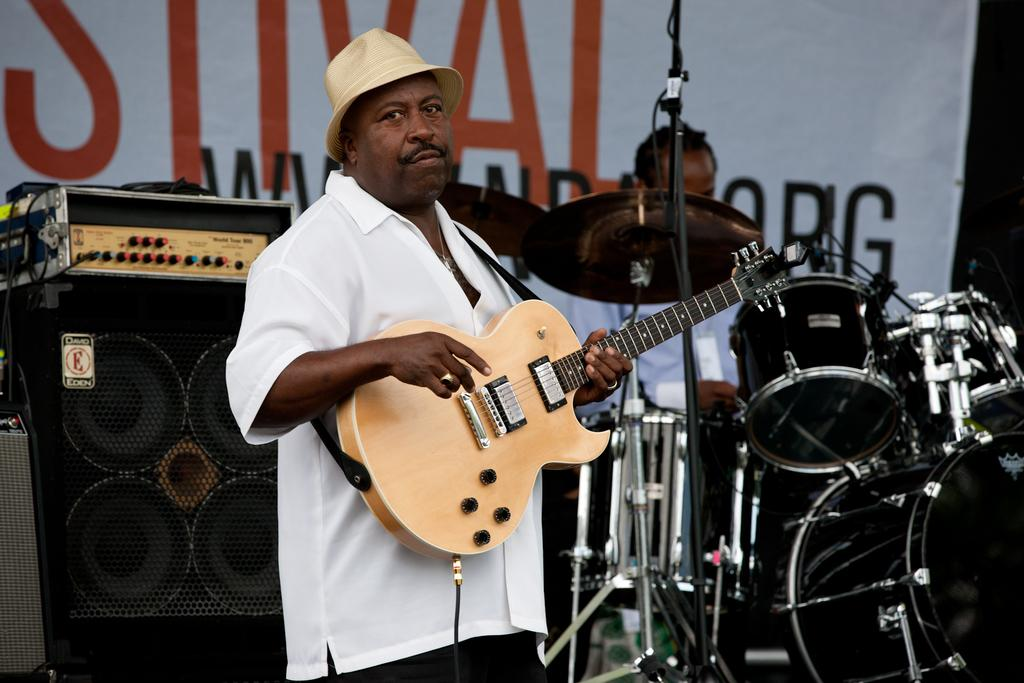What is the main subject of the image? There is a person in the image. What is the person wearing? The person is wearing a white shirt and a cap. What is the person doing in the image? The person is holding and playing a guitar. What can be seen in the background of the image? There are drums, a speaker, and a hoarding in the background of the image. Are there any other people in the image? Yes, there is a person sitting and playing drums in the background of the image. What type of flesh can be seen on the face of the person playing the guitar? There is no flesh visible on the face of the person playing the guitar in the image. How many drums are visible on the face of the person playing the guitar? There are no drums visible on the face of the person playing the guitar in the image. 